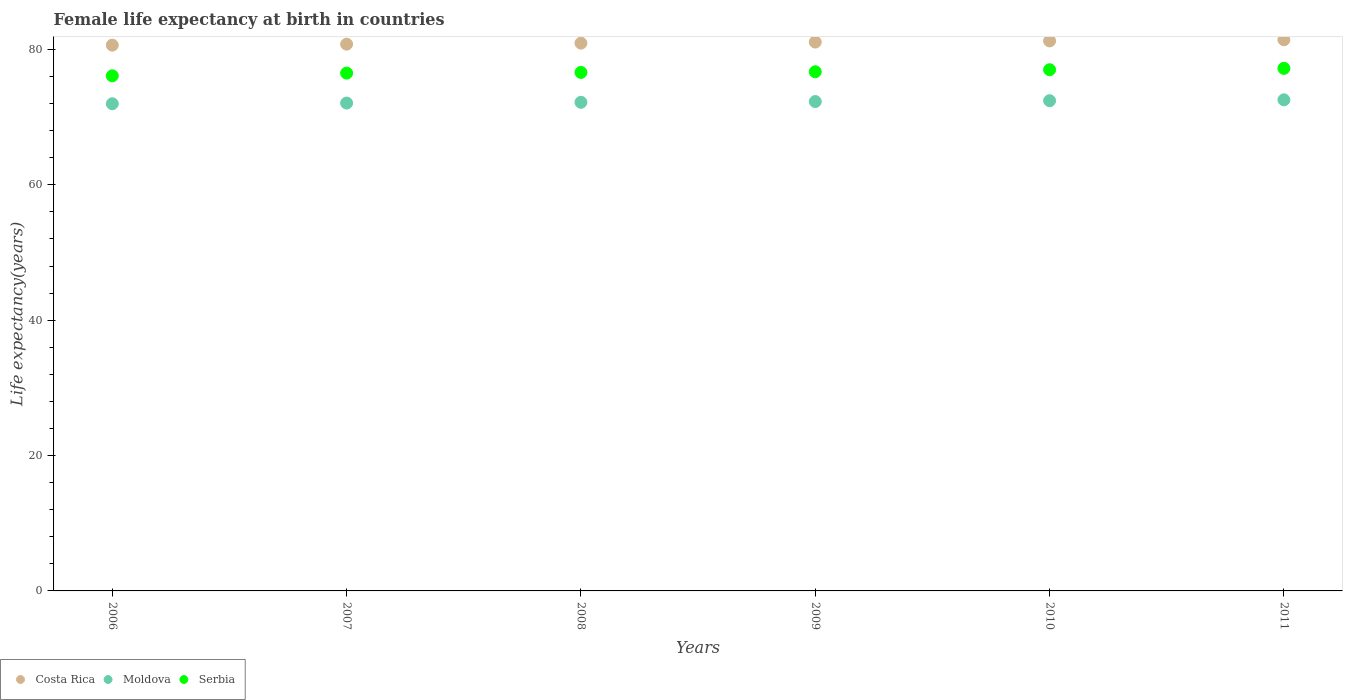How many different coloured dotlines are there?
Keep it short and to the point. 3. What is the female life expectancy at birth in Moldova in 2007?
Give a very brief answer. 72.08. Across all years, what is the maximum female life expectancy at birth in Moldova?
Your answer should be compact. 72.55. Across all years, what is the minimum female life expectancy at birth in Costa Rica?
Your response must be concise. 80.63. In which year was the female life expectancy at birth in Serbia maximum?
Give a very brief answer. 2011. What is the total female life expectancy at birth in Moldova in the graph?
Your answer should be compact. 433.5. What is the difference between the female life expectancy at birth in Serbia in 2006 and that in 2007?
Offer a very short reply. -0.4. What is the difference between the female life expectancy at birth in Serbia in 2010 and the female life expectancy at birth in Costa Rica in 2007?
Provide a short and direct response. -3.77. What is the average female life expectancy at birth in Moldova per year?
Provide a short and direct response. 72.25. In the year 2009, what is the difference between the female life expectancy at birth in Costa Rica and female life expectancy at birth in Serbia?
Your response must be concise. 4.39. In how many years, is the female life expectancy at birth in Costa Rica greater than 68 years?
Your answer should be very brief. 6. What is the ratio of the female life expectancy at birth in Moldova in 2010 to that in 2011?
Offer a terse response. 1. Is the female life expectancy at birth in Moldova in 2006 less than that in 2009?
Your answer should be very brief. Yes. Is the difference between the female life expectancy at birth in Costa Rica in 2007 and 2009 greater than the difference between the female life expectancy at birth in Serbia in 2007 and 2009?
Your response must be concise. No. What is the difference between the highest and the second highest female life expectancy at birth in Serbia?
Your answer should be very brief. 0.2. What is the difference between the highest and the lowest female life expectancy at birth in Moldova?
Make the answer very short. 0.58. Is the female life expectancy at birth in Costa Rica strictly greater than the female life expectancy at birth in Moldova over the years?
Offer a very short reply. Yes. Is the female life expectancy at birth in Serbia strictly less than the female life expectancy at birth in Moldova over the years?
Make the answer very short. No. What is the difference between two consecutive major ticks on the Y-axis?
Give a very brief answer. 20. Are the values on the major ticks of Y-axis written in scientific E-notation?
Your answer should be compact. No. Does the graph contain grids?
Make the answer very short. No. What is the title of the graph?
Offer a very short reply. Female life expectancy at birth in countries. Does "Cyprus" appear as one of the legend labels in the graph?
Give a very brief answer. No. What is the label or title of the Y-axis?
Provide a succinct answer. Life expectancy(years). What is the Life expectancy(years) in Costa Rica in 2006?
Provide a short and direct response. 80.63. What is the Life expectancy(years) of Moldova in 2006?
Provide a short and direct response. 71.97. What is the Life expectancy(years) in Serbia in 2006?
Keep it short and to the point. 76.1. What is the Life expectancy(years) in Costa Rica in 2007?
Keep it short and to the point. 80.77. What is the Life expectancy(years) in Moldova in 2007?
Keep it short and to the point. 72.08. What is the Life expectancy(years) in Serbia in 2007?
Provide a short and direct response. 76.5. What is the Life expectancy(years) in Costa Rica in 2008?
Offer a very short reply. 80.93. What is the Life expectancy(years) of Moldova in 2008?
Provide a short and direct response. 72.18. What is the Life expectancy(years) of Serbia in 2008?
Your response must be concise. 76.6. What is the Life expectancy(years) in Costa Rica in 2009?
Your answer should be compact. 81.09. What is the Life expectancy(years) of Moldova in 2009?
Give a very brief answer. 72.3. What is the Life expectancy(years) in Serbia in 2009?
Offer a very short reply. 76.7. What is the Life expectancy(years) of Costa Rica in 2010?
Your response must be concise. 81.25. What is the Life expectancy(years) in Moldova in 2010?
Offer a terse response. 72.42. What is the Life expectancy(years) in Costa Rica in 2011?
Offer a terse response. 81.42. What is the Life expectancy(years) of Moldova in 2011?
Your answer should be very brief. 72.55. What is the Life expectancy(years) of Serbia in 2011?
Your response must be concise. 77.2. Across all years, what is the maximum Life expectancy(years) in Costa Rica?
Offer a very short reply. 81.42. Across all years, what is the maximum Life expectancy(years) of Moldova?
Offer a terse response. 72.55. Across all years, what is the maximum Life expectancy(years) of Serbia?
Make the answer very short. 77.2. Across all years, what is the minimum Life expectancy(years) of Costa Rica?
Ensure brevity in your answer.  80.63. Across all years, what is the minimum Life expectancy(years) of Moldova?
Offer a very short reply. 71.97. Across all years, what is the minimum Life expectancy(years) in Serbia?
Provide a succinct answer. 76.1. What is the total Life expectancy(years) of Costa Rica in the graph?
Offer a terse response. 486.1. What is the total Life expectancy(years) of Moldova in the graph?
Provide a succinct answer. 433.5. What is the total Life expectancy(years) of Serbia in the graph?
Offer a very short reply. 460.1. What is the difference between the Life expectancy(years) in Costa Rica in 2006 and that in 2007?
Make the answer very short. -0.14. What is the difference between the Life expectancy(years) in Moldova in 2006 and that in 2007?
Keep it short and to the point. -0.1. What is the difference between the Life expectancy(years) in Costa Rica in 2006 and that in 2008?
Keep it short and to the point. -0.29. What is the difference between the Life expectancy(years) of Moldova in 2006 and that in 2008?
Offer a terse response. -0.21. What is the difference between the Life expectancy(years) in Costa Rica in 2006 and that in 2009?
Offer a very short reply. -0.46. What is the difference between the Life expectancy(years) of Moldova in 2006 and that in 2009?
Your response must be concise. -0.33. What is the difference between the Life expectancy(years) of Serbia in 2006 and that in 2009?
Offer a very short reply. -0.6. What is the difference between the Life expectancy(years) in Costa Rica in 2006 and that in 2010?
Your answer should be compact. -0.62. What is the difference between the Life expectancy(years) of Moldova in 2006 and that in 2010?
Your response must be concise. -0.45. What is the difference between the Life expectancy(years) of Costa Rica in 2006 and that in 2011?
Make the answer very short. -0.79. What is the difference between the Life expectancy(years) of Moldova in 2006 and that in 2011?
Provide a succinct answer. -0.58. What is the difference between the Life expectancy(years) of Serbia in 2006 and that in 2011?
Offer a terse response. -1.1. What is the difference between the Life expectancy(years) in Costa Rica in 2007 and that in 2008?
Keep it short and to the point. -0.15. What is the difference between the Life expectancy(years) in Moldova in 2007 and that in 2008?
Provide a short and direct response. -0.11. What is the difference between the Life expectancy(years) of Costa Rica in 2007 and that in 2009?
Provide a succinct answer. -0.31. What is the difference between the Life expectancy(years) in Moldova in 2007 and that in 2009?
Provide a succinct answer. -0.22. What is the difference between the Life expectancy(years) in Costa Rica in 2007 and that in 2010?
Your response must be concise. -0.48. What is the difference between the Life expectancy(years) of Moldova in 2007 and that in 2010?
Offer a very short reply. -0.35. What is the difference between the Life expectancy(years) of Serbia in 2007 and that in 2010?
Offer a terse response. -0.5. What is the difference between the Life expectancy(years) in Costa Rica in 2007 and that in 2011?
Provide a succinct answer. -0.65. What is the difference between the Life expectancy(years) in Moldova in 2007 and that in 2011?
Offer a very short reply. -0.48. What is the difference between the Life expectancy(years) in Costa Rica in 2008 and that in 2009?
Provide a succinct answer. -0.16. What is the difference between the Life expectancy(years) in Moldova in 2008 and that in 2009?
Give a very brief answer. -0.11. What is the difference between the Life expectancy(years) in Costa Rica in 2008 and that in 2010?
Provide a short and direct response. -0.33. What is the difference between the Life expectancy(years) of Moldova in 2008 and that in 2010?
Offer a very short reply. -0.24. What is the difference between the Life expectancy(years) of Costa Rica in 2008 and that in 2011?
Your answer should be very brief. -0.5. What is the difference between the Life expectancy(years) in Moldova in 2008 and that in 2011?
Give a very brief answer. -0.37. What is the difference between the Life expectancy(years) of Costa Rica in 2009 and that in 2010?
Give a very brief answer. -0.17. What is the difference between the Life expectancy(years) of Moldova in 2009 and that in 2010?
Offer a very short reply. -0.12. What is the difference between the Life expectancy(years) of Costa Rica in 2009 and that in 2011?
Your response must be concise. -0.34. What is the difference between the Life expectancy(years) of Moldova in 2009 and that in 2011?
Keep it short and to the point. -0.26. What is the difference between the Life expectancy(years) of Serbia in 2009 and that in 2011?
Your answer should be very brief. -0.5. What is the difference between the Life expectancy(years) of Costa Rica in 2010 and that in 2011?
Provide a short and direct response. -0.17. What is the difference between the Life expectancy(years) in Moldova in 2010 and that in 2011?
Ensure brevity in your answer.  -0.13. What is the difference between the Life expectancy(years) of Costa Rica in 2006 and the Life expectancy(years) of Moldova in 2007?
Offer a terse response. 8.55. What is the difference between the Life expectancy(years) in Costa Rica in 2006 and the Life expectancy(years) in Serbia in 2007?
Offer a terse response. 4.13. What is the difference between the Life expectancy(years) of Moldova in 2006 and the Life expectancy(years) of Serbia in 2007?
Make the answer very short. -4.53. What is the difference between the Life expectancy(years) of Costa Rica in 2006 and the Life expectancy(years) of Moldova in 2008?
Keep it short and to the point. 8.45. What is the difference between the Life expectancy(years) in Costa Rica in 2006 and the Life expectancy(years) in Serbia in 2008?
Give a very brief answer. 4.03. What is the difference between the Life expectancy(years) of Moldova in 2006 and the Life expectancy(years) of Serbia in 2008?
Your answer should be compact. -4.63. What is the difference between the Life expectancy(years) of Costa Rica in 2006 and the Life expectancy(years) of Moldova in 2009?
Provide a short and direct response. 8.33. What is the difference between the Life expectancy(years) of Costa Rica in 2006 and the Life expectancy(years) of Serbia in 2009?
Keep it short and to the point. 3.93. What is the difference between the Life expectancy(years) of Moldova in 2006 and the Life expectancy(years) of Serbia in 2009?
Give a very brief answer. -4.73. What is the difference between the Life expectancy(years) in Costa Rica in 2006 and the Life expectancy(years) in Moldova in 2010?
Your response must be concise. 8.21. What is the difference between the Life expectancy(years) of Costa Rica in 2006 and the Life expectancy(years) of Serbia in 2010?
Give a very brief answer. 3.63. What is the difference between the Life expectancy(years) in Moldova in 2006 and the Life expectancy(years) in Serbia in 2010?
Offer a terse response. -5.03. What is the difference between the Life expectancy(years) in Costa Rica in 2006 and the Life expectancy(years) in Moldova in 2011?
Your response must be concise. 8.08. What is the difference between the Life expectancy(years) in Costa Rica in 2006 and the Life expectancy(years) in Serbia in 2011?
Provide a succinct answer. 3.43. What is the difference between the Life expectancy(years) in Moldova in 2006 and the Life expectancy(years) in Serbia in 2011?
Keep it short and to the point. -5.23. What is the difference between the Life expectancy(years) in Costa Rica in 2007 and the Life expectancy(years) in Moldova in 2008?
Your answer should be compact. 8.59. What is the difference between the Life expectancy(years) of Costa Rica in 2007 and the Life expectancy(years) of Serbia in 2008?
Your answer should be compact. 4.17. What is the difference between the Life expectancy(years) in Moldova in 2007 and the Life expectancy(years) in Serbia in 2008?
Keep it short and to the point. -4.52. What is the difference between the Life expectancy(years) of Costa Rica in 2007 and the Life expectancy(years) of Moldova in 2009?
Offer a very short reply. 8.48. What is the difference between the Life expectancy(years) of Costa Rica in 2007 and the Life expectancy(years) of Serbia in 2009?
Give a very brief answer. 4.07. What is the difference between the Life expectancy(years) of Moldova in 2007 and the Life expectancy(years) of Serbia in 2009?
Offer a terse response. -4.62. What is the difference between the Life expectancy(years) in Costa Rica in 2007 and the Life expectancy(years) in Moldova in 2010?
Offer a terse response. 8.35. What is the difference between the Life expectancy(years) of Costa Rica in 2007 and the Life expectancy(years) of Serbia in 2010?
Offer a terse response. 3.77. What is the difference between the Life expectancy(years) in Moldova in 2007 and the Life expectancy(years) in Serbia in 2010?
Make the answer very short. -4.92. What is the difference between the Life expectancy(years) of Costa Rica in 2007 and the Life expectancy(years) of Moldova in 2011?
Give a very brief answer. 8.22. What is the difference between the Life expectancy(years) in Costa Rica in 2007 and the Life expectancy(years) in Serbia in 2011?
Provide a succinct answer. 3.57. What is the difference between the Life expectancy(years) of Moldova in 2007 and the Life expectancy(years) of Serbia in 2011?
Make the answer very short. -5.12. What is the difference between the Life expectancy(years) in Costa Rica in 2008 and the Life expectancy(years) in Moldova in 2009?
Make the answer very short. 8.63. What is the difference between the Life expectancy(years) of Costa Rica in 2008 and the Life expectancy(years) of Serbia in 2009?
Provide a short and direct response. 4.23. What is the difference between the Life expectancy(years) of Moldova in 2008 and the Life expectancy(years) of Serbia in 2009?
Offer a very short reply. -4.52. What is the difference between the Life expectancy(years) of Costa Rica in 2008 and the Life expectancy(years) of Moldova in 2010?
Ensure brevity in your answer.  8.5. What is the difference between the Life expectancy(years) of Costa Rica in 2008 and the Life expectancy(years) of Serbia in 2010?
Provide a succinct answer. 3.93. What is the difference between the Life expectancy(years) in Moldova in 2008 and the Life expectancy(years) in Serbia in 2010?
Your response must be concise. -4.82. What is the difference between the Life expectancy(years) of Costa Rica in 2008 and the Life expectancy(years) of Moldova in 2011?
Provide a short and direct response. 8.37. What is the difference between the Life expectancy(years) in Costa Rica in 2008 and the Life expectancy(years) in Serbia in 2011?
Keep it short and to the point. 3.73. What is the difference between the Life expectancy(years) in Moldova in 2008 and the Life expectancy(years) in Serbia in 2011?
Make the answer very short. -5.02. What is the difference between the Life expectancy(years) of Costa Rica in 2009 and the Life expectancy(years) of Moldova in 2010?
Give a very brief answer. 8.66. What is the difference between the Life expectancy(years) of Costa Rica in 2009 and the Life expectancy(years) of Serbia in 2010?
Ensure brevity in your answer.  4.09. What is the difference between the Life expectancy(years) in Moldova in 2009 and the Life expectancy(years) in Serbia in 2010?
Keep it short and to the point. -4.7. What is the difference between the Life expectancy(years) of Costa Rica in 2009 and the Life expectancy(years) of Moldova in 2011?
Keep it short and to the point. 8.53. What is the difference between the Life expectancy(years) in Costa Rica in 2009 and the Life expectancy(years) in Serbia in 2011?
Your response must be concise. 3.89. What is the difference between the Life expectancy(years) of Moldova in 2009 and the Life expectancy(years) of Serbia in 2011?
Your answer should be very brief. -4.9. What is the difference between the Life expectancy(years) of Costa Rica in 2010 and the Life expectancy(years) of Moldova in 2011?
Make the answer very short. 8.7. What is the difference between the Life expectancy(years) of Costa Rica in 2010 and the Life expectancy(years) of Serbia in 2011?
Keep it short and to the point. 4.05. What is the difference between the Life expectancy(years) of Moldova in 2010 and the Life expectancy(years) of Serbia in 2011?
Provide a short and direct response. -4.78. What is the average Life expectancy(years) in Costa Rica per year?
Your answer should be very brief. 81.02. What is the average Life expectancy(years) in Moldova per year?
Offer a terse response. 72.25. What is the average Life expectancy(years) of Serbia per year?
Offer a very short reply. 76.68. In the year 2006, what is the difference between the Life expectancy(years) of Costa Rica and Life expectancy(years) of Moldova?
Keep it short and to the point. 8.66. In the year 2006, what is the difference between the Life expectancy(years) of Costa Rica and Life expectancy(years) of Serbia?
Provide a succinct answer. 4.53. In the year 2006, what is the difference between the Life expectancy(years) of Moldova and Life expectancy(years) of Serbia?
Make the answer very short. -4.13. In the year 2007, what is the difference between the Life expectancy(years) in Costa Rica and Life expectancy(years) in Moldova?
Your response must be concise. 8.7. In the year 2007, what is the difference between the Life expectancy(years) in Costa Rica and Life expectancy(years) in Serbia?
Your response must be concise. 4.27. In the year 2007, what is the difference between the Life expectancy(years) in Moldova and Life expectancy(years) in Serbia?
Give a very brief answer. -4.42. In the year 2008, what is the difference between the Life expectancy(years) in Costa Rica and Life expectancy(years) in Moldova?
Provide a succinct answer. 8.74. In the year 2008, what is the difference between the Life expectancy(years) of Costa Rica and Life expectancy(years) of Serbia?
Offer a very short reply. 4.33. In the year 2008, what is the difference between the Life expectancy(years) of Moldova and Life expectancy(years) of Serbia?
Your response must be concise. -4.42. In the year 2009, what is the difference between the Life expectancy(years) in Costa Rica and Life expectancy(years) in Moldova?
Make the answer very short. 8.79. In the year 2009, what is the difference between the Life expectancy(years) of Costa Rica and Life expectancy(years) of Serbia?
Make the answer very short. 4.39. In the year 2009, what is the difference between the Life expectancy(years) of Moldova and Life expectancy(years) of Serbia?
Offer a terse response. -4.4. In the year 2010, what is the difference between the Life expectancy(years) in Costa Rica and Life expectancy(years) in Moldova?
Keep it short and to the point. 8.83. In the year 2010, what is the difference between the Life expectancy(years) of Costa Rica and Life expectancy(years) of Serbia?
Offer a very short reply. 4.25. In the year 2010, what is the difference between the Life expectancy(years) of Moldova and Life expectancy(years) of Serbia?
Give a very brief answer. -4.58. In the year 2011, what is the difference between the Life expectancy(years) of Costa Rica and Life expectancy(years) of Moldova?
Ensure brevity in your answer.  8.87. In the year 2011, what is the difference between the Life expectancy(years) in Costa Rica and Life expectancy(years) in Serbia?
Give a very brief answer. 4.22. In the year 2011, what is the difference between the Life expectancy(years) in Moldova and Life expectancy(years) in Serbia?
Keep it short and to the point. -4.65. What is the ratio of the Life expectancy(years) of Costa Rica in 2006 to that in 2007?
Your response must be concise. 1. What is the ratio of the Life expectancy(years) in Moldova in 2006 to that in 2007?
Ensure brevity in your answer.  1. What is the ratio of the Life expectancy(years) in Serbia in 2006 to that in 2007?
Make the answer very short. 0.99. What is the ratio of the Life expectancy(years) in Costa Rica in 2006 to that in 2008?
Your answer should be compact. 1. What is the ratio of the Life expectancy(years) of Moldova in 2006 to that in 2008?
Offer a very short reply. 1. What is the ratio of the Life expectancy(years) in Serbia in 2006 to that in 2008?
Keep it short and to the point. 0.99. What is the ratio of the Life expectancy(years) of Costa Rica in 2006 to that in 2009?
Your answer should be compact. 0.99. What is the ratio of the Life expectancy(years) in Costa Rica in 2006 to that in 2010?
Give a very brief answer. 0.99. What is the ratio of the Life expectancy(years) in Moldova in 2006 to that in 2010?
Keep it short and to the point. 0.99. What is the ratio of the Life expectancy(years) in Serbia in 2006 to that in 2010?
Offer a terse response. 0.99. What is the ratio of the Life expectancy(years) in Costa Rica in 2006 to that in 2011?
Your answer should be compact. 0.99. What is the ratio of the Life expectancy(years) of Moldova in 2006 to that in 2011?
Make the answer very short. 0.99. What is the ratio of the Life expectancy(years) of Serbia in 2006 to that in 2011?
Offer a terse response. 0.99. What is the ratio of the Life expectancy(years) of Costa Rica in 2007 to that in 2008?
Offer a terse response. 1. What is the ratio of the Life expectancy(years) in Moldova in 2007 to that in 2008?
Offer a terse response. 1. What is the ratio of the Life expectancy(years) of Moldova in 2007 to that in 2009?
Provide a short and direct response. 1. What is the ratio of the Life expectancy(years) of Costa Rica in 2007 to that in 2010?
Keep it short and to the point. 0.99. What is the ratio of the Life expectancy(years) of Serbia in 2007 to that in 2011?
Your response must be concise. 0.99. What is the ratio of the Life expectancy(years) in Serbia in 2008 to that in 2009?
Give a very brief answer. 1. What is the ratio of the Life expectancy(years) of Costa Rica in 2008 to that in 2011?
Give a very brief answer. 0.99. What is the ratio of the Life expectancy(years) in Serbia in 2008 to that in 2011?
Keep it short and to the point. 0.99. What is the ratio of the Life expectancy(years) in Serbia in 2009 to that in 2010?
Your response must be concise. 1. What is the ratio of the Life expectancy(years) in Costa Rica in 2009 to that in 2011?
Keep it short and to the point. 1. What is the ratio of the Life expectancy(years) of Moldova in 2009 to that in 2011?
Your answer should be very brief. 1. What is the ratio of the Life expectancy(years) of Serbia in 2009 to that in 2011?
Offer a very short reply. 0.99. What is the ratio of the Life expectancy(years) in Costa Rica in 2010 to that in 2011?
Provide a succinct answer. 1. What is the ratio of the Life expectancy(years) in Moldova in 2010 to that in 2011?
Your answer should be compact. 1. What is the ratio of the Life expectancy(years) of Serbia in 2010 to that in 2011?
Provide a succinct answer. 1. What is the difference between the highest and the second highest Life expectancy(years) in Costa Rica?
Offer a very short reply. 0.17. What is the difference between the highest and the second highest Life expectancy(years) of Moldova?
Offer a terse response. 0.13. What is the difference between the highest and the lowest Life expectancy(years) of Costa Rica?
Your answer should be compact. 0.79. What is the difference between the highest and the lowest Life expectancy(years) in Moldova?
Your response must be concise. 0.58. What is the difference between the highest and the lowest Life expectancy(years) of Serbia?
Provide a short and direct response. 1.1. 